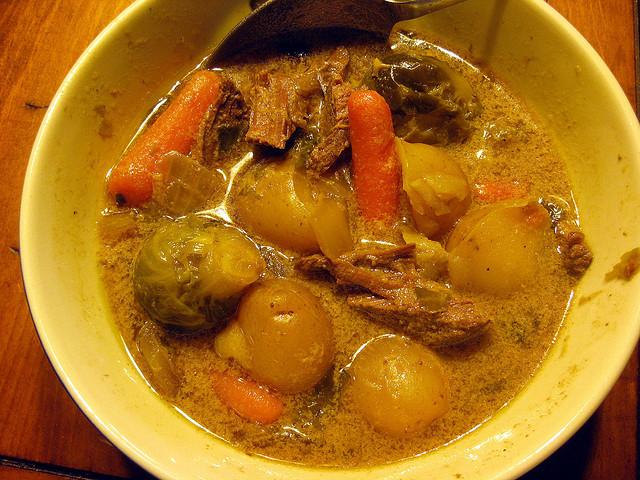What type of meat is in this dish?
Give a very brief answer. Beef. Are there carrots in this dish?
Concise answer only. Yes. What color is the bowl?
Concise answer only. Yellow. 